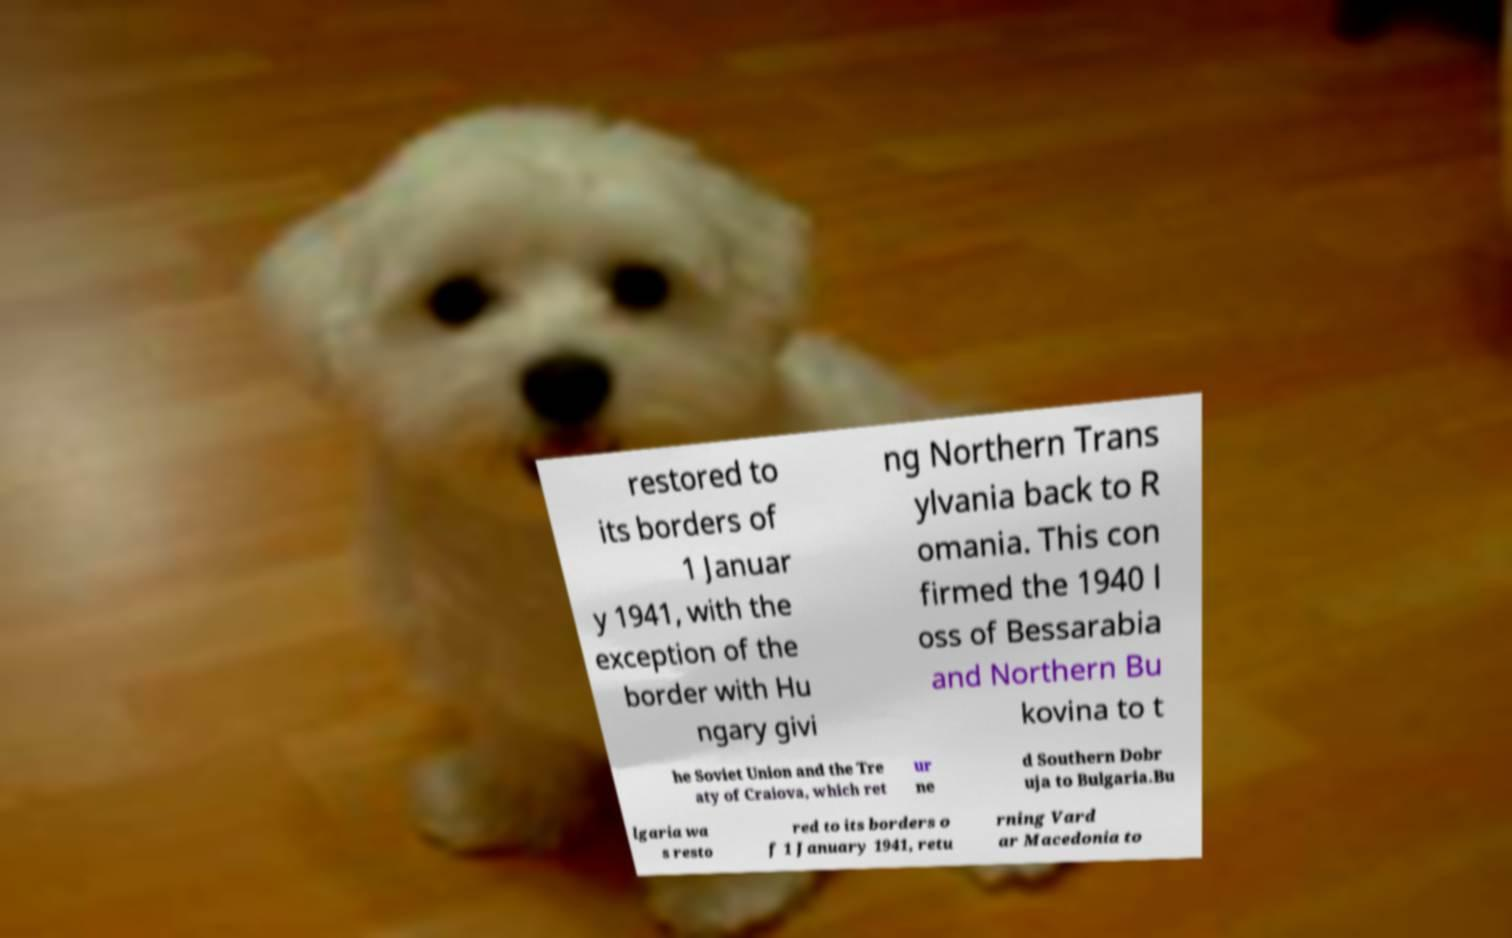What messages or text are displayed in this image? I need them in a readable, typed format. restored to its borders of 1 Januar y 1941, with the exception of the border with Hu ngary givi ng Northern Trans ylvania back to R omania. This con firmed the 1940 l oss of Bessarabia and Northern Bu kovina to t he Soviet Union and the Tre aty of Craiova, which ret ur ne d Southern Dobr uja to Bulgaria.Bu lgaria wa s resto red to its borders o f 1 January 1941, retu rning Vard ar Macedonia to 